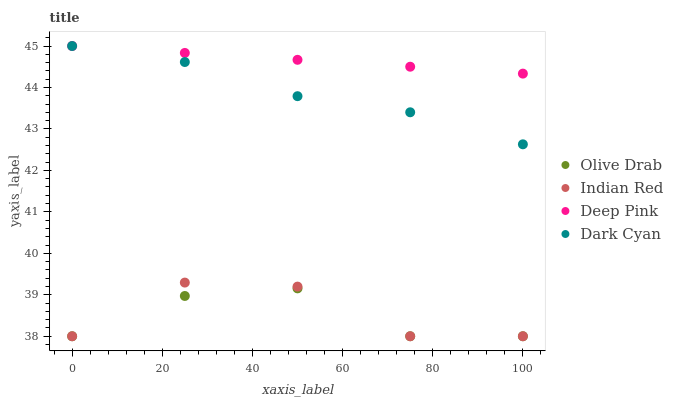Does Olive Drab have the minimum area under the curve?
Answer yes or no. Yes. Does Deep Pink have the maximum area under the curve?
Answer yes or no. Yes. Does Indian Red have the minimum area under the curve?
Answer yes or no. No. Does Indian Red have the maximum area under the curve?
Answer yes or no. No. Is Deep Pink the smoothest?
Answer yes or no. Yes. Is Indian Red the roughest?
Answer yes or no. Yes. Is Indian Red the smoothest?
Answer yes or no. No. Is Deep Pink the roughest?
Answer yes or no. No. Does Indian Red have the lowest value?
Answer yes or no. Yes. Does Deep Pink have the lowest value?
Answer yes or no. No. Does Deep Pink have the highest value?
Answer yes or no. Yes. Does Indian Red have the highest value?
Answer yes or no. No. Is Olive Drab less than Dark Cyan?
Answer yes or no. Yes. Is Deep Pink greater than Olive Drab?
Answer yes or no. Yes. Does Indian Red intersect Olive Drab?
Answer yes or no. Yes. Is Indian Red less than Olive Drab?
Answer yes or no. No. Is Indian Red greater than Olive Drab?
Answer yes or no. No. Does Olive Drab intersect Dark Cyan?
Answer yes or no. No. 